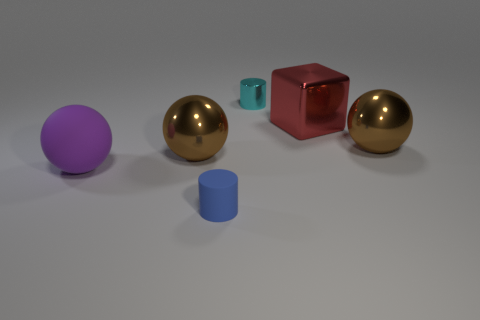There is a blue object; is its size the same as the metal object behind the red object?
Your answer should be very brief. Yes. There is a metal thing that is in front of the small cyan object and left of the cube; what is its color?
Provide a short and direct response. Brown. Are there any brown balls that are right of the tiny object behind the large block?
Your response must be concise. Yes. Are there an equal number of spheres that are behind the red cube and gray cylinders?
Offer a very short reply. Yes. There is a big metal thing behind the metallic ball to the right of the cyan shiny cylinder; what number of big metal things are in front of it?
Give a very brief answer. 2. Is there a red object that has the same size as the purple object?
Offer a terse response. Yes. Is the number of things behind the tiny metal object less than the number of metallic objects?
Your response must be concise. Yes. What material is the brown ball that is behind the large brown object that is left of the matte object that is in front of the big purple matte sphere made of?
Your response must be concise. Metal. Are there more big brown shiny spheres to the right of the cyan shiny thing than large balls in front of the blue cylinder?
Offer a very short reply. Yes. What number of rubber things are big yellow things or cyan things?
Provide a short and direct response. 0. 